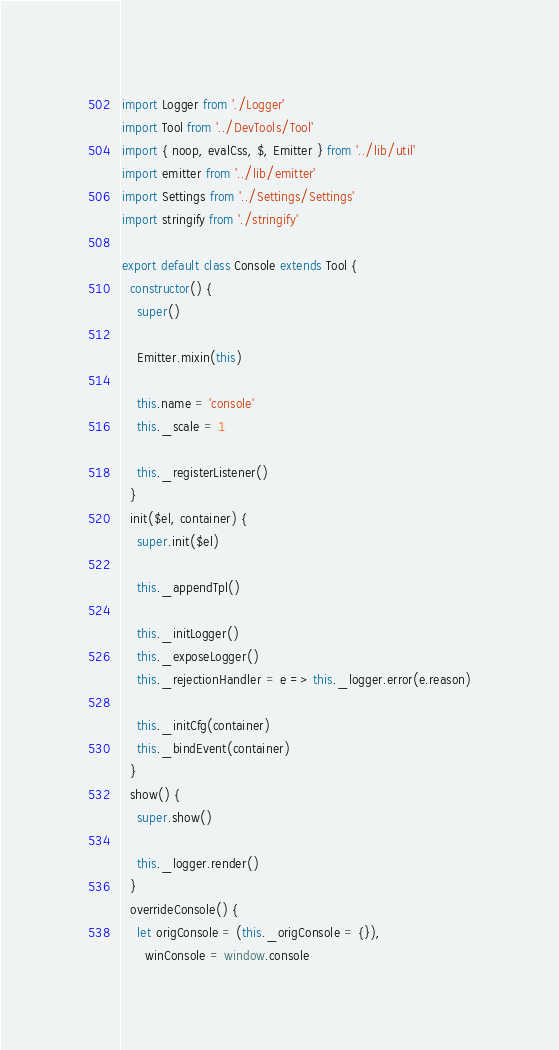<code> <loc_0><loc_0><loc_500><loc_500><_JavaScript_>import Logger from './Logger'
import Tool from '../DevTools/Tool'
import { noop, evalCss, $, Emitter } from '../lib/util'
import emitter from '../lib/emitter'
import Settings from '../Settings/Settings'
import stringify from './stringify'

export default class Console extends Tool {
  constructor() {
    super()

    Emitter.mixin(this)

    this.name = 'console'
    this._scale = 1

    this._registerListener()
  }
  init($el, container) {
    super.init($el)

    this._appendTpl()

    this._initLogger()
    this._exposeLogger()
    this._rejectionHandler = e => this._logger.error(e.reason)

    this._initCfg(container)
    this._bindEvent(container)
  }
  show() {
    super.show()

    this._logger.render()
  }
  overrideConsole() {
    let origConsole = (this._origConsole = {}),
      winConsole = window.console
</code> 